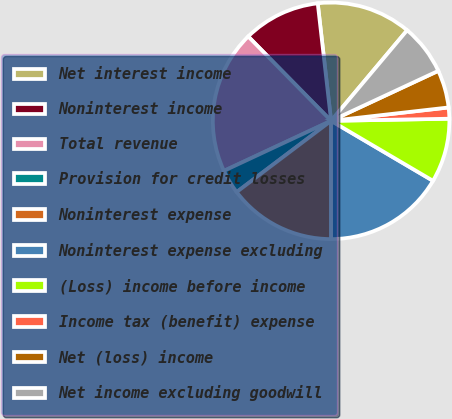<chart> <loc_0><loc_0><loc_500><loc_500><pie_chart><fcel>Net interest income<fcel>Noninterest income<fcel>Total revenue<fcel>Provision for credit losses<fcel>Noninterest expense<fcel>Noninterest expense excluding<fcel>(Loss) income before income<fcel>Income tax (benefit) expense<fcel>Net (loss) income<fcel>Net income excluding goodwill<nl><fcel>12.92%<fcel>10.56%<fcel>19.59%<fcel>3.33%<fcel>14.72%<fcel>16.53%<fcel>8.75%<fcel>1.52%<fcel>5.14%<fcel>6.94%<nl></chart> 